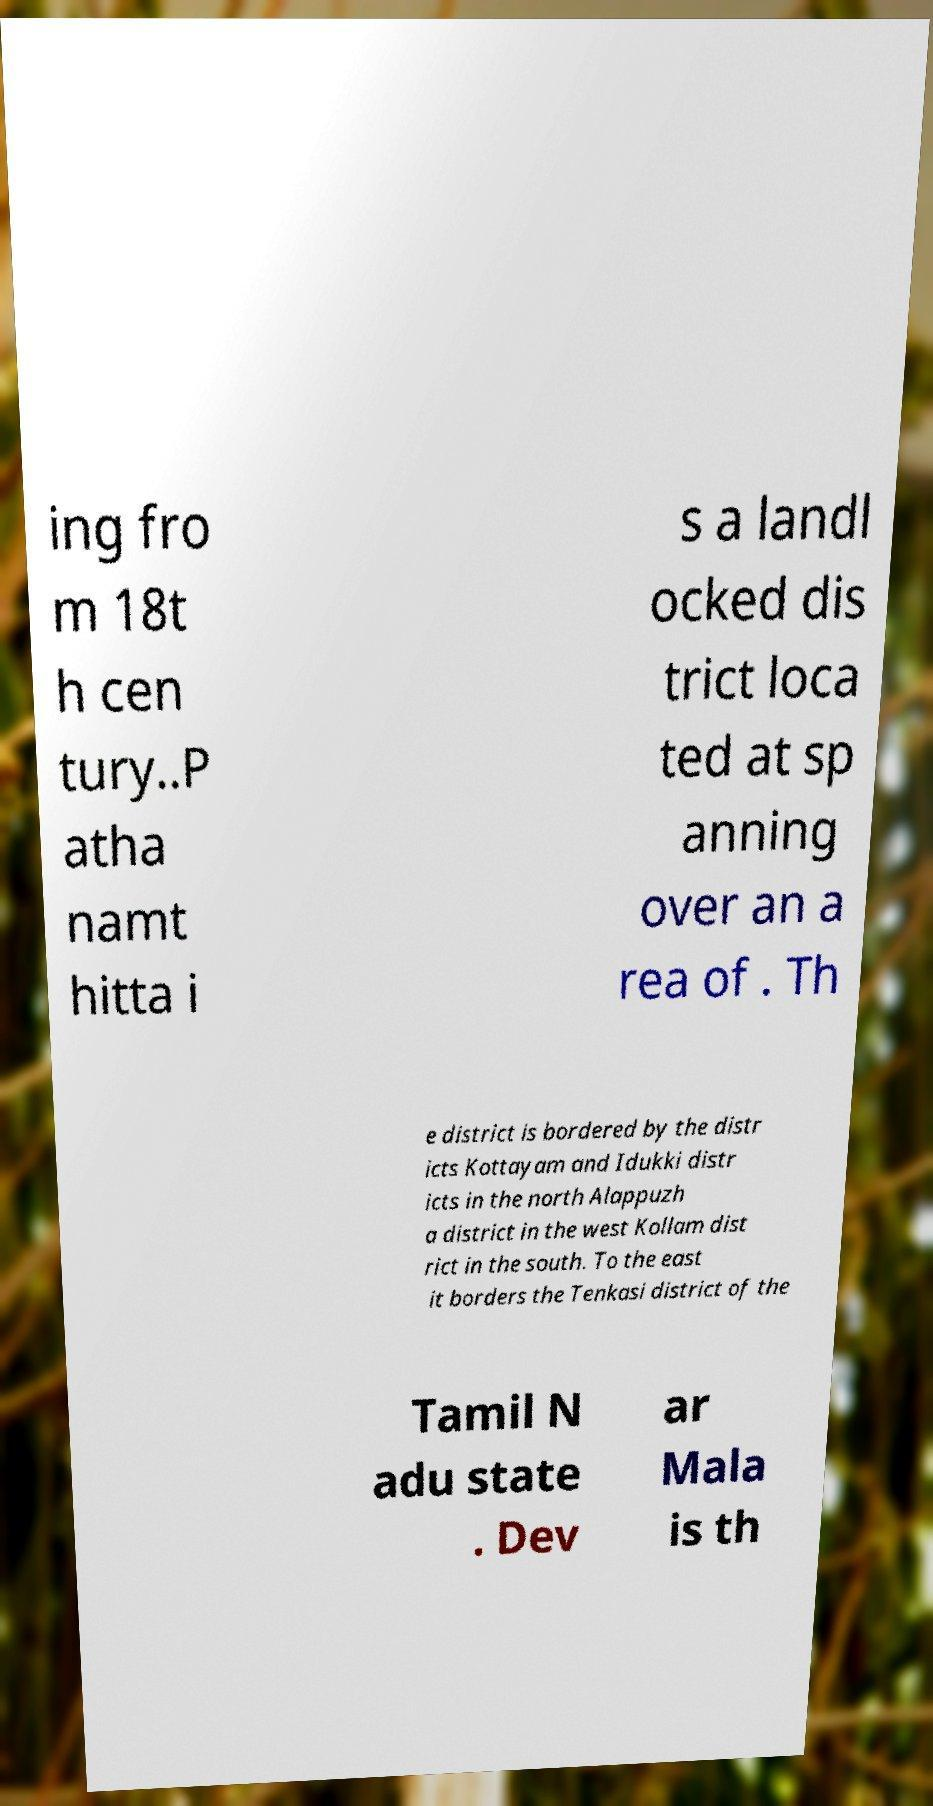Could you extract and type out the text from this image? ing fro m 18t h cen tury..P atha namt hitta i s a landl ocked dis trict loca ted at sp anning over an a rea of . Th e district is bordered by the distr icts Kottayam and Idukki distr icts in the north Alappuzh a district in the west Kollam dist rict in the south. To the east it borders the Tenkasi district of the Tamil N adu state . Dev ar Mala is th 